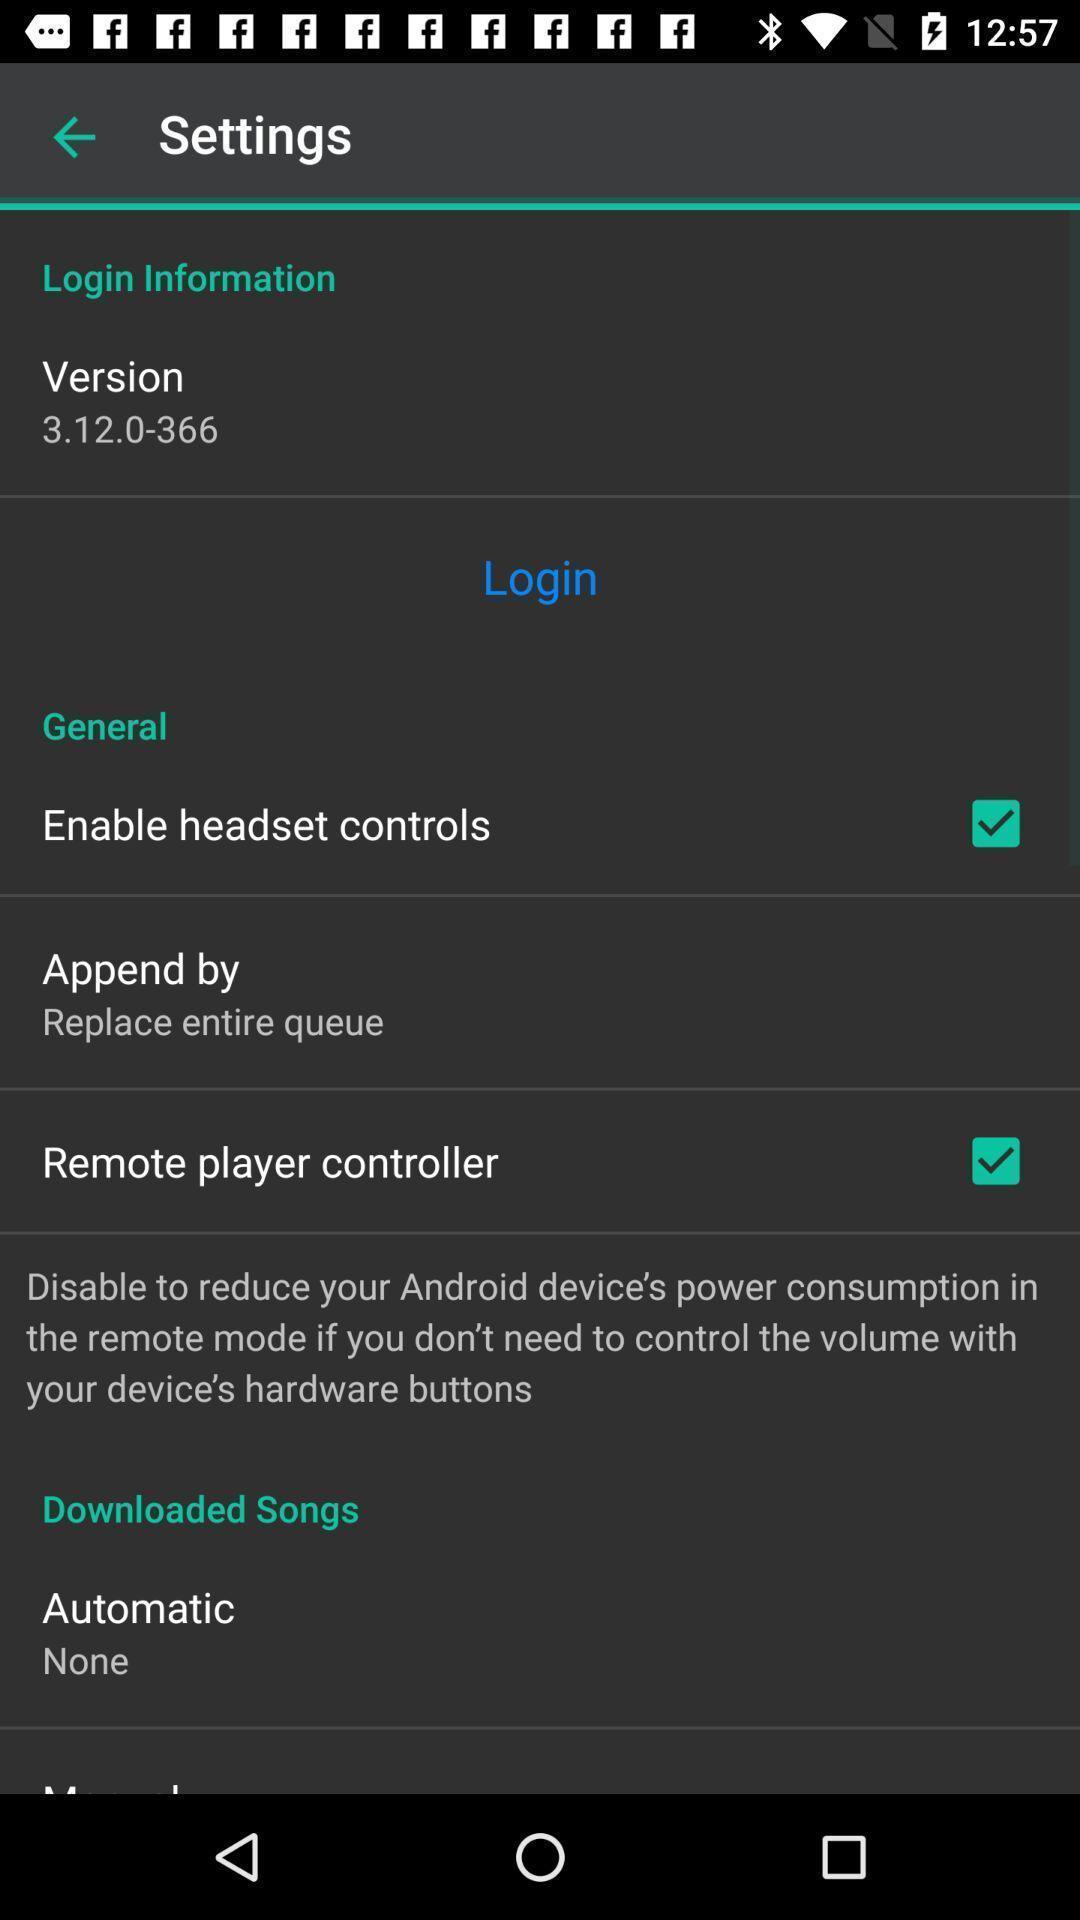Describe the key features of this screenshot. Settings page. 